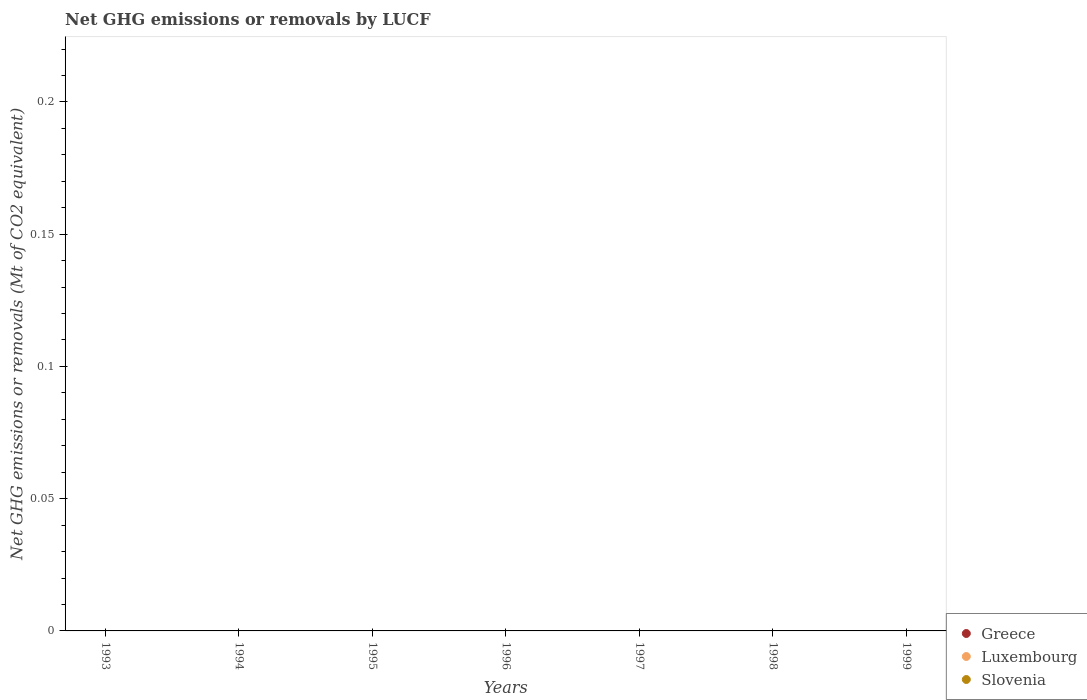Across all years, what is the minimum net GHG emissions or removals by LUCF in Greece?
Offer a very short reply. 0. What is the total net GHG emissions or removals by LUCF in Greece in the graph?
Give a very brief answer. 0. What is the difference between the net GHG emissions or removals by LUCF in Greece in 1993 and the net GHG emissions or removals by LUCF in Luxembourg in 1996?
Give a very brief answer. 0. What is the average net GHG emissions or removals by LUCF in Luxembourg per year?
Ensure brevity in your answer.  0. Does the net GHG emissions or removals by LUCF in Luxembourg monotonically increase over the years?
Ensure brevity in your answer.  No. Is the net GHG emissions or removals by LUCF in Luxembourg strictly less than the net GHG emissions or removals by LUCF in Greece over the years?
Offer a terse response. No. What is the difference between two consecutive major ticks on the Y-axis?
Offer a very short reply. 0.05. Does the graph contain any zero values?
Offer a very short reply. Yes. Does the graph contain grids?
Keep it short and to the point. No. How are the legend labels stacked?
Offer a very short reply. Vertical. What is the title of the graph?
Offer a terse response. Net GHG emissions or removals by LUCF. What is the label or title of the Y-axis?
Provide a succinct answer. Net GHG emissions or removals (Mt of CO2 equivalent). What is the Net GHG emissions or removals (Mt of CO2 equivalent) of Greece in 1993?
Your response must be concise. 0. What is the Net GHG emissions or removals (Mt of CO2 equivalent) of Luxembourg in 1993?
Your answer should be very brief. 0. What is the Net GHG emissions or removals (Mt of CO2 equivalent) in Slovenia in 1993?
Make the answer very short. 0. What is the Net GHG emissions or removals (Mt of CO2 equivalent) of Luxembourg in 1994?
Offer a very short reply. 0. What is the Net GHG emissions or removals (Mt of CO2 equivalent) of Greece in 1995?
Your answer should be compact. 0. What is the Net GHG emissions or removals (Mt of CO2 equivalent) in Slovenia in 1995?
Your response must be concise. 0. What is the Net GHG emissions or removals (Mt of CO2 equivalent) of Greece in 1996?
Your answer should be compact. 0. What is the Net GHG emissions or removals (Mt of CO2 equivalent) of Luxembourg in 1996?
Make the answer very short. 0. What is the Net GHG emissions or removals (Mt of CO2 equivalent) in Slovenia in 1996?
Give a very brief answer. 0. What is the Net GHG emissions or removals (Mt of CO2 equivalent) of Greece in 1997?
Ensure brevity in your answer.  0. What is the Net GHG emissions or removals (Mt of CO2 equivalent) in Greece in 1998?
Ensure brevity in your answer.  0. What is the Net GHG emissions or removals (Mt of CO2 equivalent) of Luxembourg in 1998?
Offer a very short reply. 0. What is the Net GHG emissions or removals (Mt of CO2 equivalent) of Slovenia in 1999?
Make the answer very short. 0. What is the average Net GHG emissions or removals (Mt of CO2 equivalent) of Greece per year?
Provide a succinct answer. 0. 